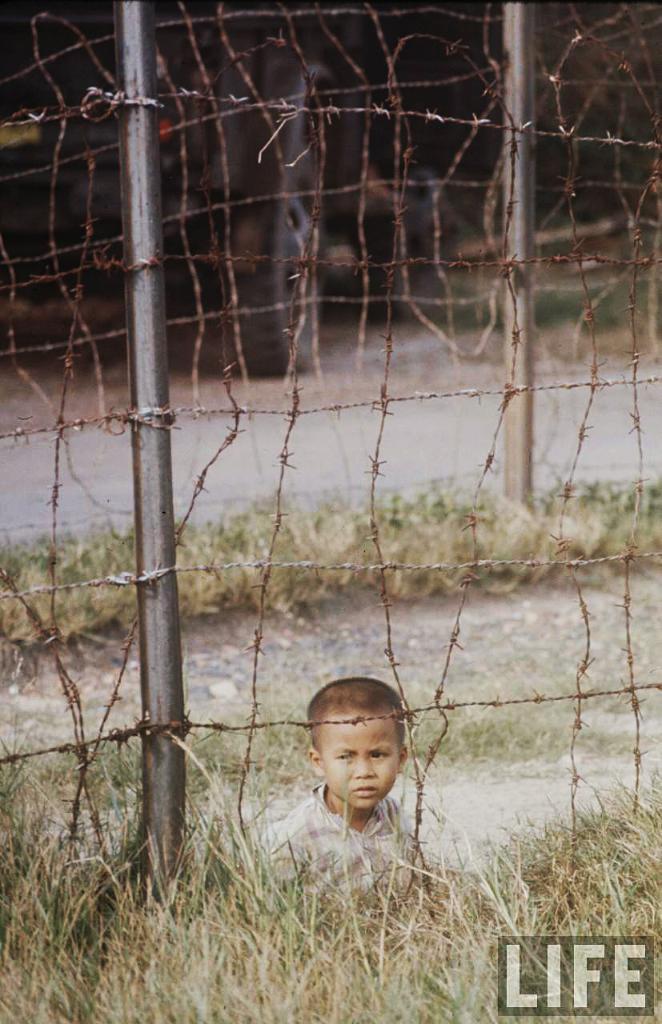Can you describe this image briefly? In this picture I can see the grass and I see the fencing in front and behind the fencing I can see a boy and I see the watermark on the right bottom corner of this image. 